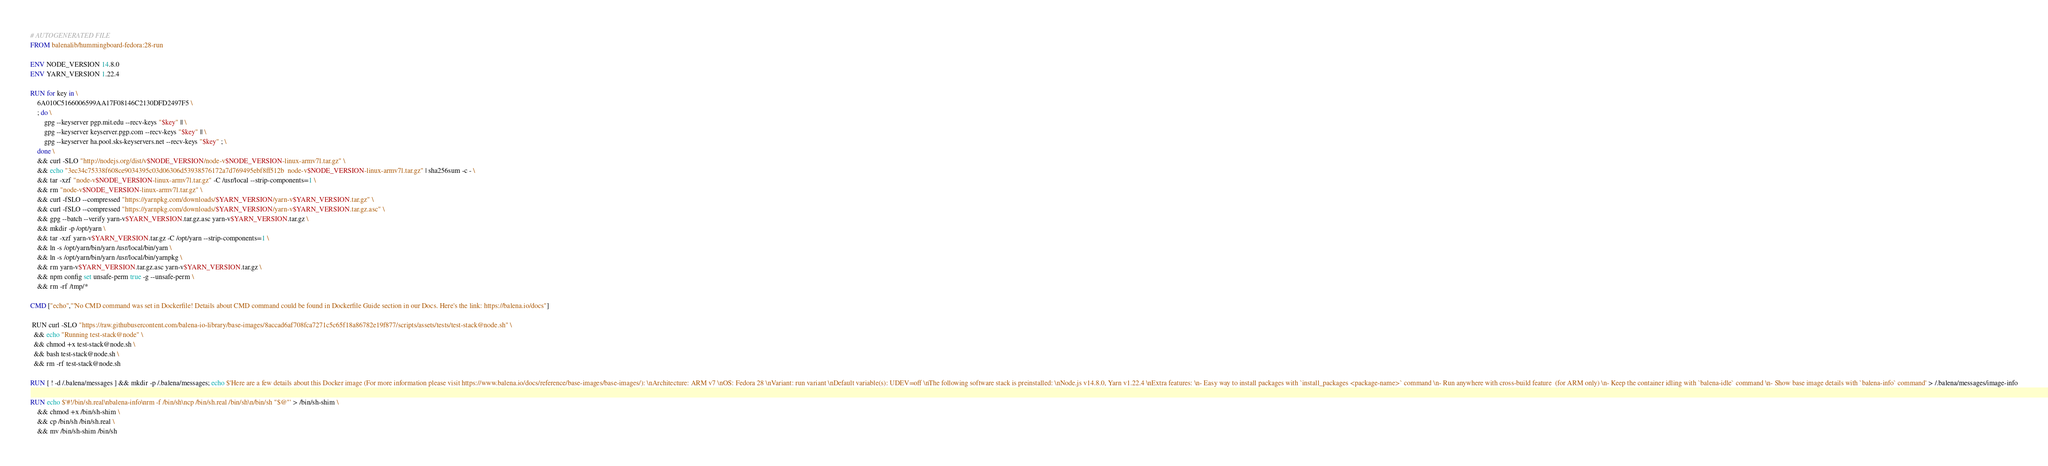<code> <loc_0><loc_0><loc_500><loc_500><_Dockerfile_># AUTOGENERATED FILE
FROM balenalib/hummingboard-fedora:28-run

ENV NODE_VERSION 14.8.0
ENV YARN_VERSION 1.22.4

RUN for key in \
	6A010C5166006599AA17F08146C2130DFD2497F5 \
	; do \
		gpg --keyserver pgp.mit.edu --recv-keys "$key" || \
		gpg --keyserver keyserver.pgp.com --recv-keys "$key" || \
		gpg --keyserver ha.pool.sks-keyservers.net --recv-keys "$key" ; \
	done \
	&& curl -SLO "http://nodejs.org/dist/v$NODE_VERSION/node-v$NODE_VERSION-linux-armv7l.tar.gz" \
	&& echo "3ec34c75338f608ce9034395c03d06306d53938576172a7d769495ebf8ff512b  node-v$NODE_VERSION-linux-armv7l.tar.gz" | sha256sum -c - \
	&& tar -xzf "node-v$NODE_VERSION-linux-armv7l.tar.gz" -C /usr/local --strip-components=1 \
	&& rm "node-v$NODE_VERSION-linux-armv7l.tar.gz" \
	&& curl -fSLO --compressed "https://yarnpkg.com/downloads/$YARN_VERSION/yarn-v$YARN_VERSION.tar.gz" \
	&& curl -fSLO --compressed "https://yarnpkg.com/downloads/$YARN_VERSION/yarn-v$YARN_VERSION.tar.gz.asc" \
	&& gpg --batch --verify yarn-v$YARN_VERSION.tar.gz.asc yarn-v$YARN_VERSION.tar.gz \
	&& mkdir -p /opt/yarn \
	&& tar -xzf yarn-v$YARN_VERSION.tar.gz -C /opt/yarn --strip-components=1 \
	&& ln -s /opt/yarn/bin/yarn /usr/local/bin/yarn \
	&& ln -s /opt/yarn/bin/yarn /usr/local/bin/yarnpkg \
	&& rm yarn-v$YARN_VERSION.tar.gz.asc yarn-v$YARN_VERSION.tar.gz \
	&& npm config set unsafe-perm true -g --unsafe-perm \
	&& rm -rf /tmp/*

CMD ["echo","'No CMD command was set in Dockerfile! Details about CMD command could be found in Dockerfile Guide section in our Docs. Here's the link: https://balena.io/docs"]

 RUN curl -SLO "https://raw.githubusercontent.com/balena-io-library/base-images/8accad6af708fca7271c5c65f18a86782e19f877/scripts/assets/tests/test-stack@node.sh" \
  && echo "Running test-stack@node" \
  && chmod +x test-stack@node.sh \
  && bash test-stack@node.sh \
  && rm -rf test-stack@node.sh 

RUN [ ! -d /.balena/messages ] && mkdir -p /.balena/messages; echo $'Here are a few details about this Docker image (For more information please visit https://www.balena.io/docs/reference/base-images/base-images/): \nArchitecture: ARM v7 \nOS: Fedora 28 \nVariant: run variant \nDefault variable(s): UDEV=off \nThe following software stack is preinstalled: \nNode.js v14.8.0, Yarn v1.22.4 \nExtra features: \n- Easy way to install packages with `install_packages <package-name>` command \n- Run anywhere with cross-build feature  (for ARM only) \n- Keep the container idling with `balena-idle` command \n- Show base image details with `balena-info` command' > /.balena/messages/image-info

RUN echo $'#!/bin/sh.real\nbalena-info\nrm -f /bin/sh\ncp /bin/sh.real /bin/sh\n/bin/sh "$@"' > /bin/sh-shim \
	&& chmod +x /bin/sh-shim \
	&& cp /bin/sh /bin/sh.real \
	&& mv /bin/sh-shim /bin/sh</code> 